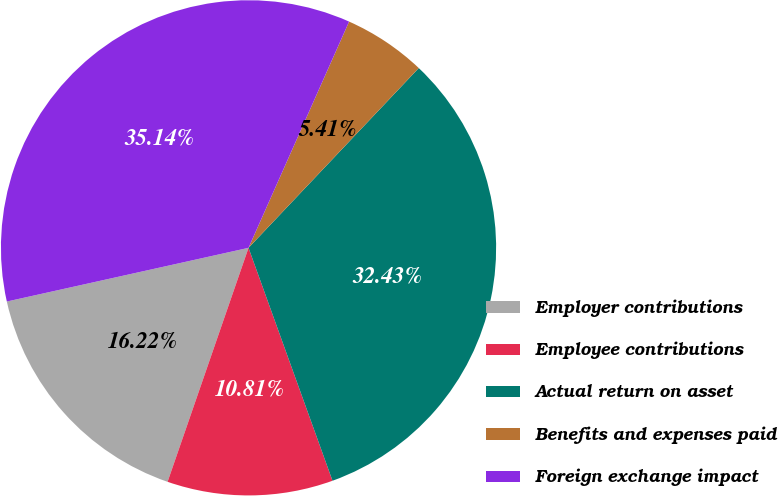Convert chart to OTSL. <chart><loc_0><loc_0><loc_500><loc_500><pie_chart><fcel>Employer contributions<fcel>Employee contributions<fcel>Actual return on asset<fcel>Benefits and expenses paid<fcel>Foreign exchange impact<nl><fcel>16.22%<fcel>10.81%<fcel>32.43%<fcel>5.41%<fcel>35.14%<nl></chart> 